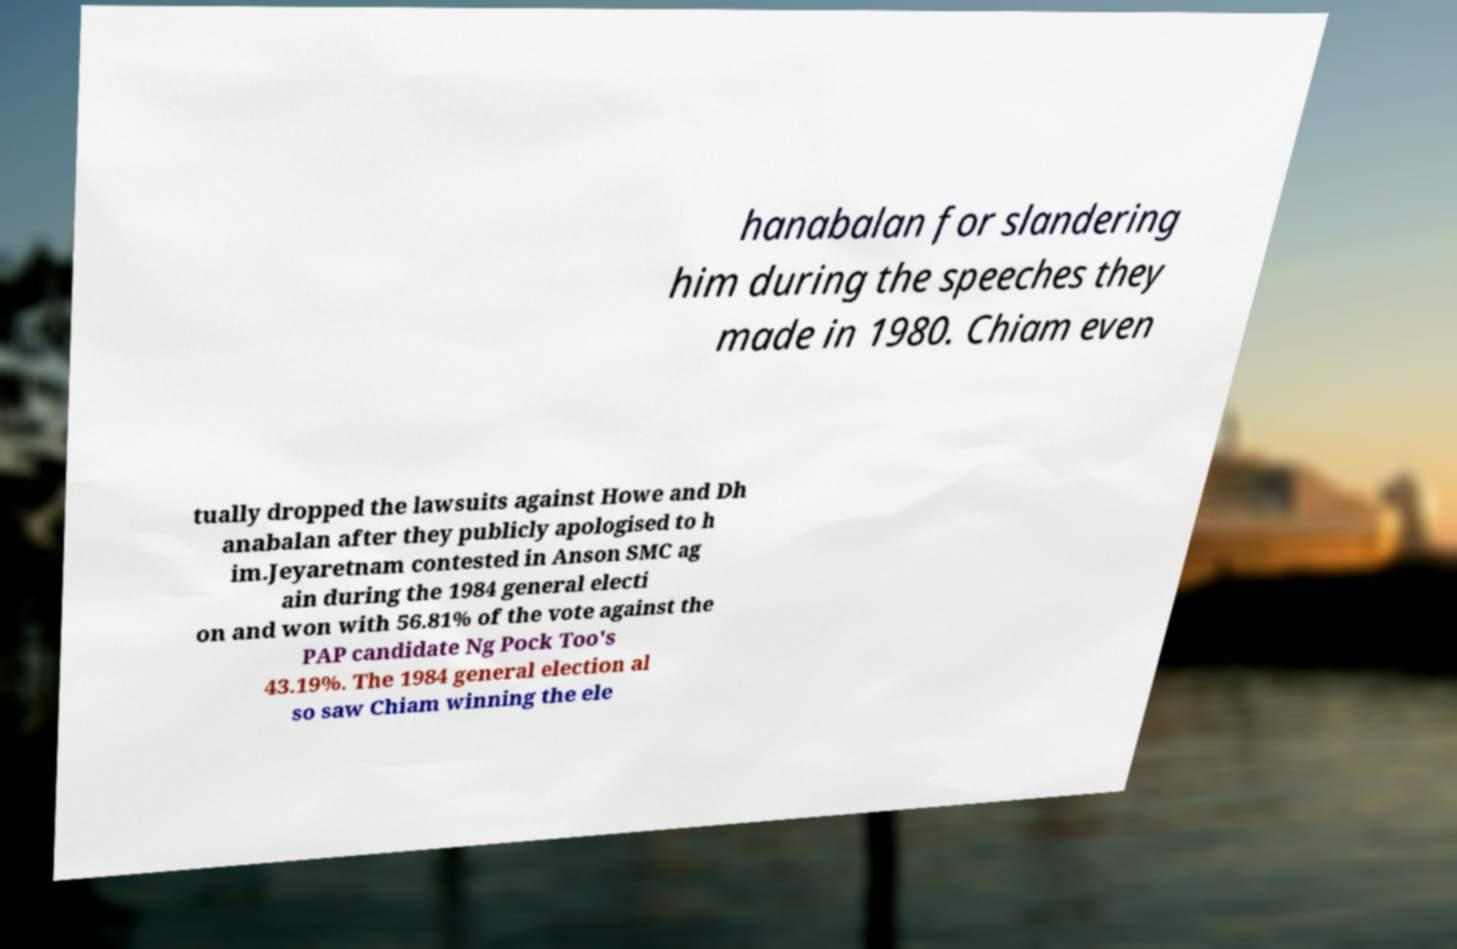I need the written content from this picture converted into text. Can you do that? hanabalan for slandering him during the speeches they made in 1980. Chiam even tually dropped the lawsuits against Howe and Dh anabalan after they publicly apologised to h im.Jeyaretnam contested in Anson SMC ag ain during the 1984 general electi on and won with 56.81% of the vote against the PAP candidate Ng Pock Too's 43.19%. The 1984 general election al so saw Chiam winning the ele 